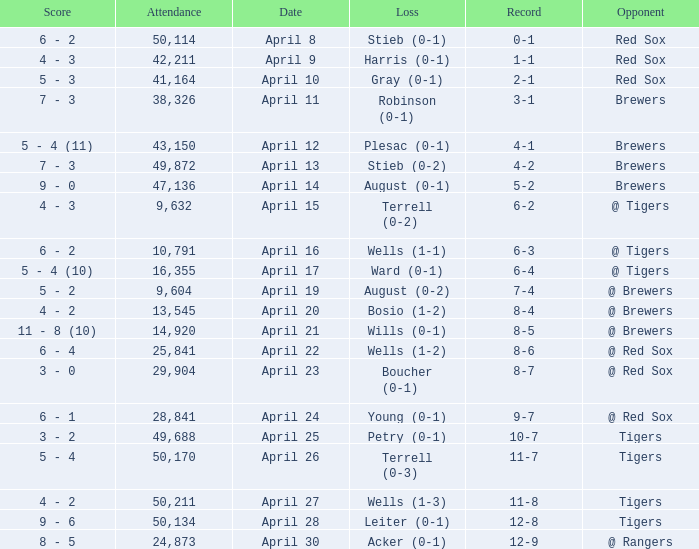Which opponent has a loss of wells (1-3)? Tigers. Give me the full table as a dictionary. {'header': ['Score', 'Attendance', 'Date', 'Loss', 'Record', 'Opponent'], 'rows': [['6 - 2', '50,114', 'April 8', 'Stieb (0-1)', '0-1', 'Red Sox'], ['4 - 3', '42,211', 'April 9', 'Harris (0-1)', '1-1', 'Red Sox'], ['5 - 3', '41,164', 'April 10', 'Gray (0-1)', '2-1', 'Red Sox'], ['7 - 3', '38,326', 'April 11', 'Robinson (0-1)', '3-1', 'Brewers'], ['5 - 4 (11)', '43,150', 'April 12', 'Plesac (0-1)', '4-1', 'Brewers'], ['7 - 3', '49,872', 'April 13', 'Stieb (0-2)', '4-2', 'Brewers'], ['9 - 0', '47,136', 'April 14', 'August (0-1)', '5-2', 'Brewers'], ['4 - 3', '9,632', 'April 15', 'Terrell (0-2)', '6-2', '@ Tigers'], ['6 - 2', '10,791', 'April 16', 'Wells (1-1)', '6-3', '@ Tigers'], ['5 - 4 (10)', '16,355', 'April 17', 'Ward (0-1)', '6-4', '@ Tigers'], ['5 - 2', '9,604', 'April 19', 'August (0-2)', '7-4', '@ Brewers'], ['4 - 2', '13,545', 'April 20', 'Bosio (1-2)', '8-4', '@ Brewers'], ['11 - 8 (10)', '14,920', 'April 21', 'Wills (0-1)', '8-5', '@ Brewers'], ['6 - 4', '25,841', 'April 22', 'Wells (1-2)', '8-6', '@ Red Sox'], ['3 - 0', '29,904', 'April 23', 'Boucher (0-1)', '8-7', '@ Red Sox'], ['6 - 1', '28,841', 'April 24', 'Young (0-1)', '9-7', '@ Red Sox'], ['3 - 2', '49,688', 'April 25', 'Petry (0-1)', '10-7', 'Tigers'], ['5 - 4', '50,170', 'April 26', 'Terrell (0-3)', '11-7', 'Tigers'], ['4 - 2', '50,211', 'April 27', 'Wells (1-3)', '11-8', 'Tigers'], ['9 - 6', '50,134', 'April 28', 'Leiter (0-1)', '12-8', 'Tigers'], ['8 - 5', '24,873', 'April 30', 'Acker (0-1)', '12-9', '@ Rangers']]} 